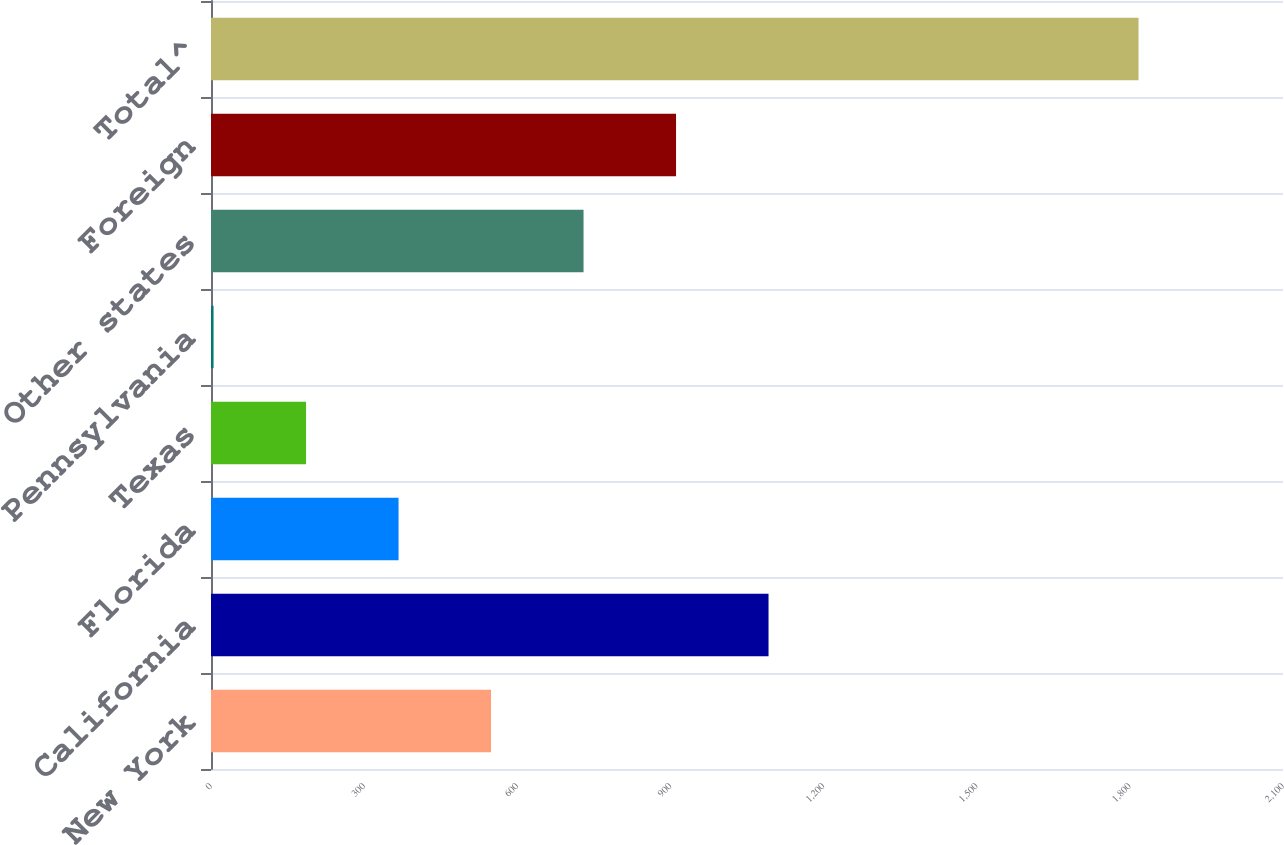Convert chart. <chart><loc_0><loc_0><loc_500><loc_500><bar_chart><fcel>New York<fcel>California<fcel>Florida<fcel>Texas<fcel>Pennsylvania<fcel>Other states<fcel>Foreign<fcel>Total^<nl><fcel>548.6<fcel>1092.2<fcel>367.4<fcel>186.2<fcel>5<fcel>729.8<fcel>911<fcel>1817<nl></chart> 